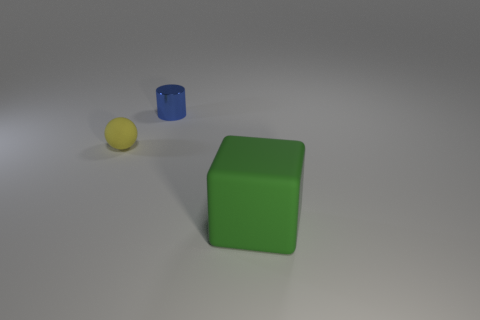Is there any other thing that has the same material as the blue thing?
Provide a succinct answer. No. How many objects are either blue things or tiny things that are behind the rubber ball?
Your response must be concise. 1. Does the matte thing that is on the left side of the green block have the same size as the shiny thing?
Your answer should be very brief. Yes. There is a object to the left of the tiny blue thing; what is it made of?
Provide a succinct answer. Rubber. Are there an equal number of big green cubes that are in front of the big matte block and tiny rubber things that are in front of the cylinder?
Your answer should be very brief. No. Are there any other things that have the same color as the ball?
Your answer should be very brief. No. How many rubber objects are either small things or small blue objects?
Your response must be concise. 1. Is the small shiny thing the same color as the tiny rubber ball?
Make the answer very short. No. Are there more yellow spheres behind the green thing than yellow matte cylinders?
Your answer should be very brief. Yes. How many other objects are there of the same material as the sphere?
Keep it short and to the point. 1. 